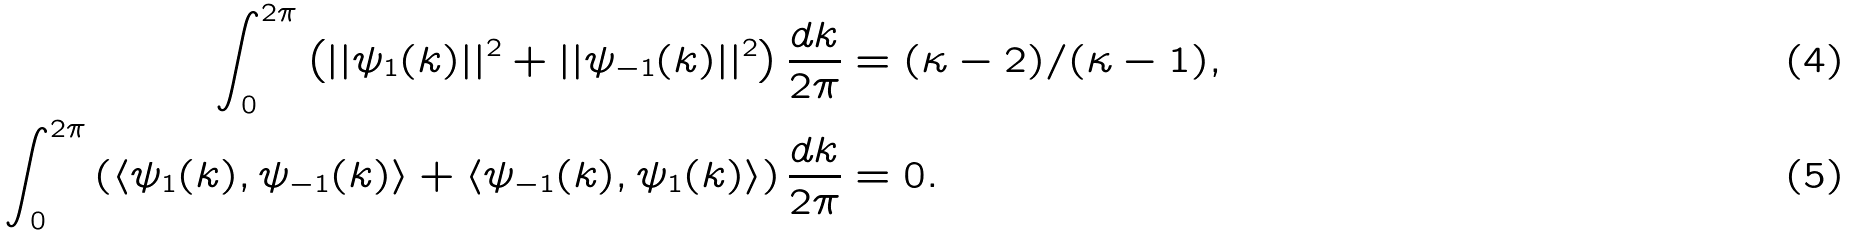<formula> <loc_0><loc_0><loc_500><loc_500>\int _ { 0 } ^ { 2 \pi } \left ( | | \psi _ { 1 } ( k ) | | ^ { 2 } + | | \psi _ { - 1 } ( k ) | | ^ { 2 } \right ) \frac { d k } { 2 \pi } & = ( \kappa - 2 ) / ( \kappa - 1 ) , \\ \int _ { 0 } ^ { 2 \pi } \left ( \langle \psi _ { 1 } ( k ) , \psi _ { - 1 } ( k ) \rangle + \langle \psi _ { - 1 } ( k ) , \psi _ { 1 } ( k ) \rangle \right ) \frac { d k } { 2 \pi } & = 0 .</formula> 